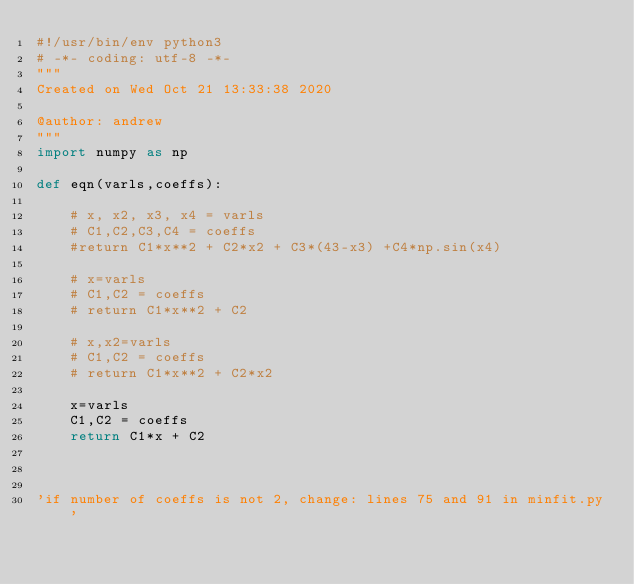Convert code to text. <code><loc_0><loc_0><loc_500><loc_500><_Python_>#!/usr/bin/env python3
# -*- coding: utf-8 -*-
"""
Created on Wed Oct 21 13:33:38 2020

@author: andrew
"""
import numpy as np

def eqn(varls,coeffs):
    
    # x, x2, x3, x4 = varls
    # C1,C2,C3,C4 = coeffs
    #return C1*x**2 + C2*x2 + C3*(43-x3) +C4*np.sin(x4)
    
    # x=varls
    # C1,C2 = coeffs
    # return C1*x**2 + C2
    
    # x,x2=varls
    # C1,C2 = coeffs
    # return C1*x**2 + C2*x2 
    
    x=varls
    C1,C2 = coeffs
    return C1*x + C2


    
'if number of coeffs is not 2, change: lines 75 and 91 in minfit.py'

</code> 